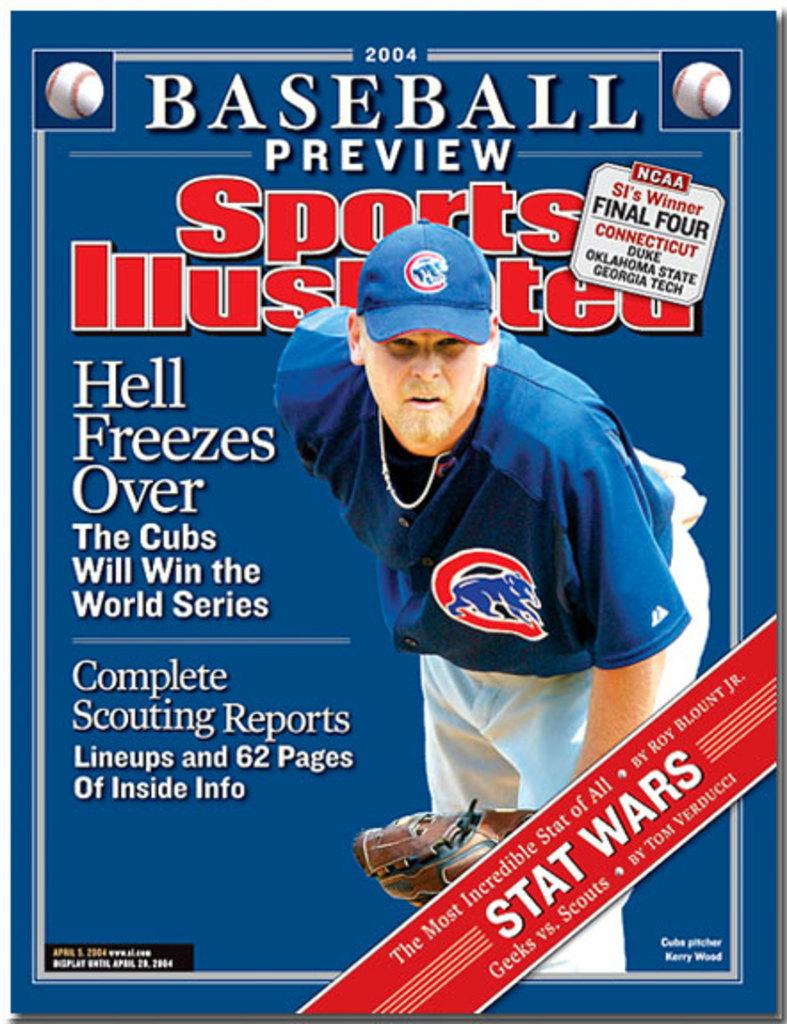Provide a one-sentence caption for the provided image. A baseball player on the front cover of a sports illustrated magazine. 